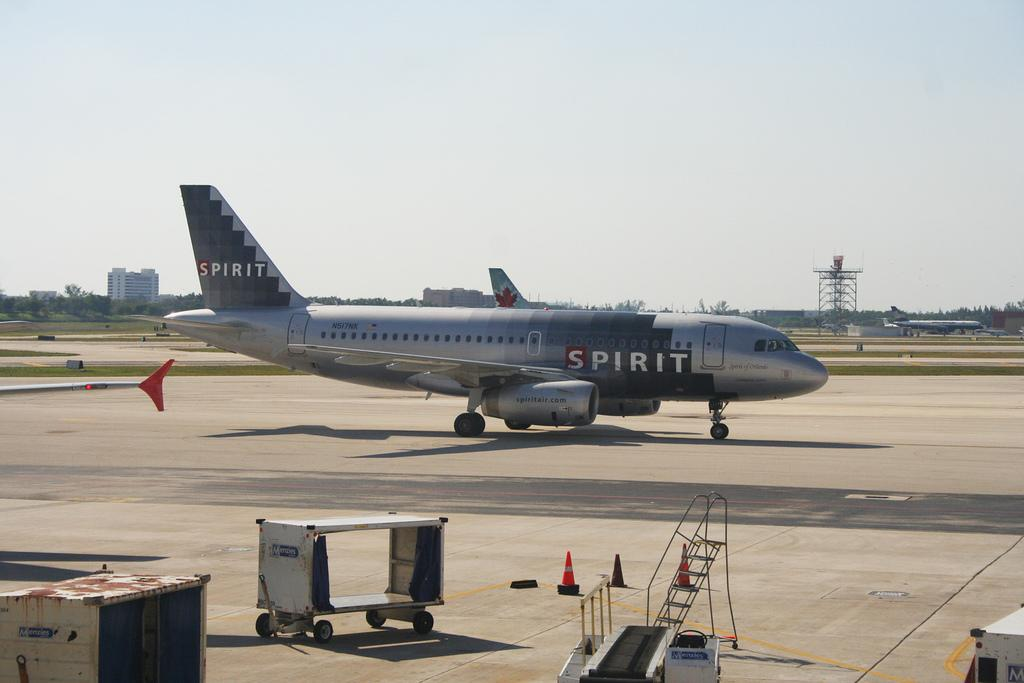<image>
Share a concise interpretation of the image provided. A large Spirit airplane that is dark gray in color. 